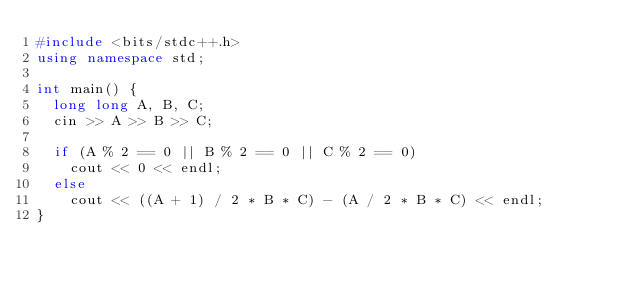Convert code to text. <code><loc_0><loc_0><loc_500><loc_500><_C++_>#include <bits/stdc++.h>
using namespace std;

int main() {
  long long A, B, C;
  cin >> A >> B >> C;

  if (A % 2 == 0 || B % 2 == 0 || C % 2 == 0)
    cout << 0 << endl;
  else
    cout << ((A + 1) / 2 * B * C) - (A / 2 * B * C) << endl;
}</code> 